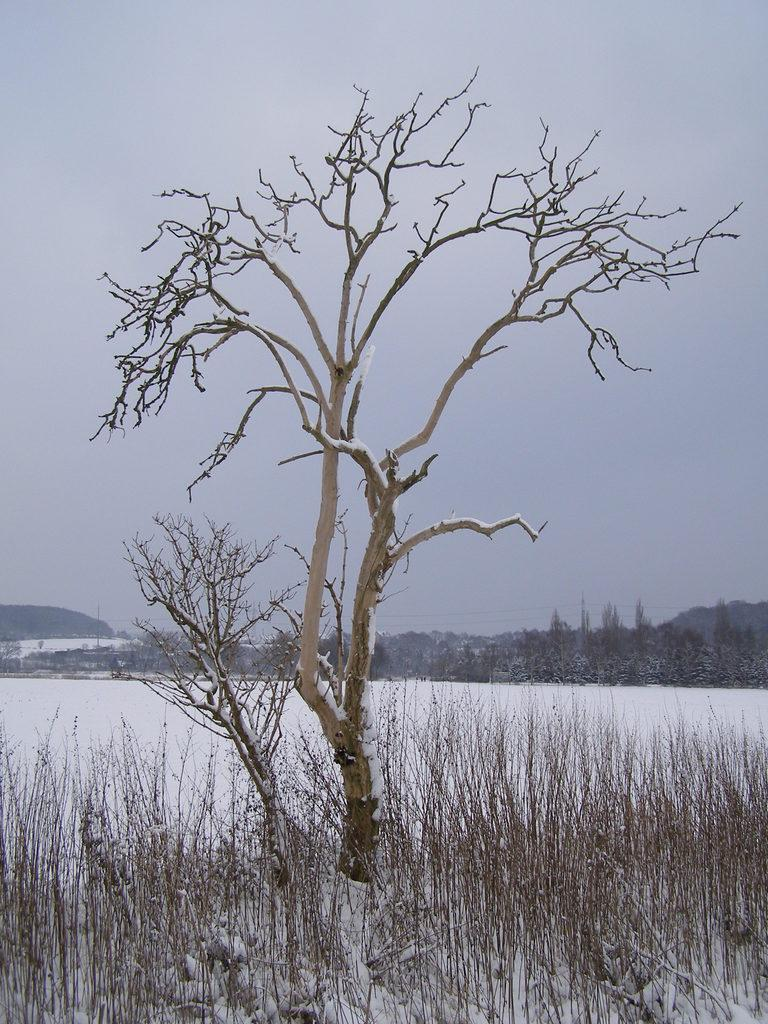What type of vegetation is present in the image? There are trees in the image. What is visible in the background of the image? There is snow and the sky visible in the background of the image. How many beads are hanging from the tree in the image? There are no beads present in the image; it only features trees and snow in the background. 